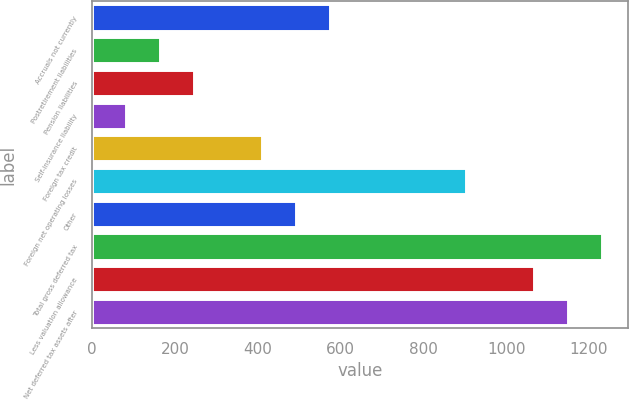Convert chart. <chart><loc_0><loc_0><loc_500><loc_500><bar_chart><fcel>Accruals not currently<fcel>Postretirement liabilities<fcel>Pension liabilities<fcel>Self-insurance liability<fcel>Foreign tax credit<fcel>Foreign net operating losses<fcel>Other<fcel>Total gross deferred tax<fcel>Less valuation allowance<fcel>Net deferred tax assets after<nl><fcel>575.28<fcel>164.58<fcel>246.72<fcel>82.44<fcel>411<fcel>903.84<fcel>493.14<fcel>1232.4<fcel>1068.12<fcel>1150.26<nl></chart> 